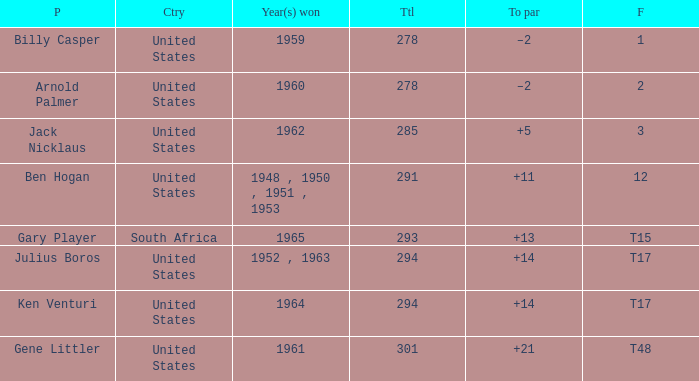Identify the country that was victorious in 1962. United States. 